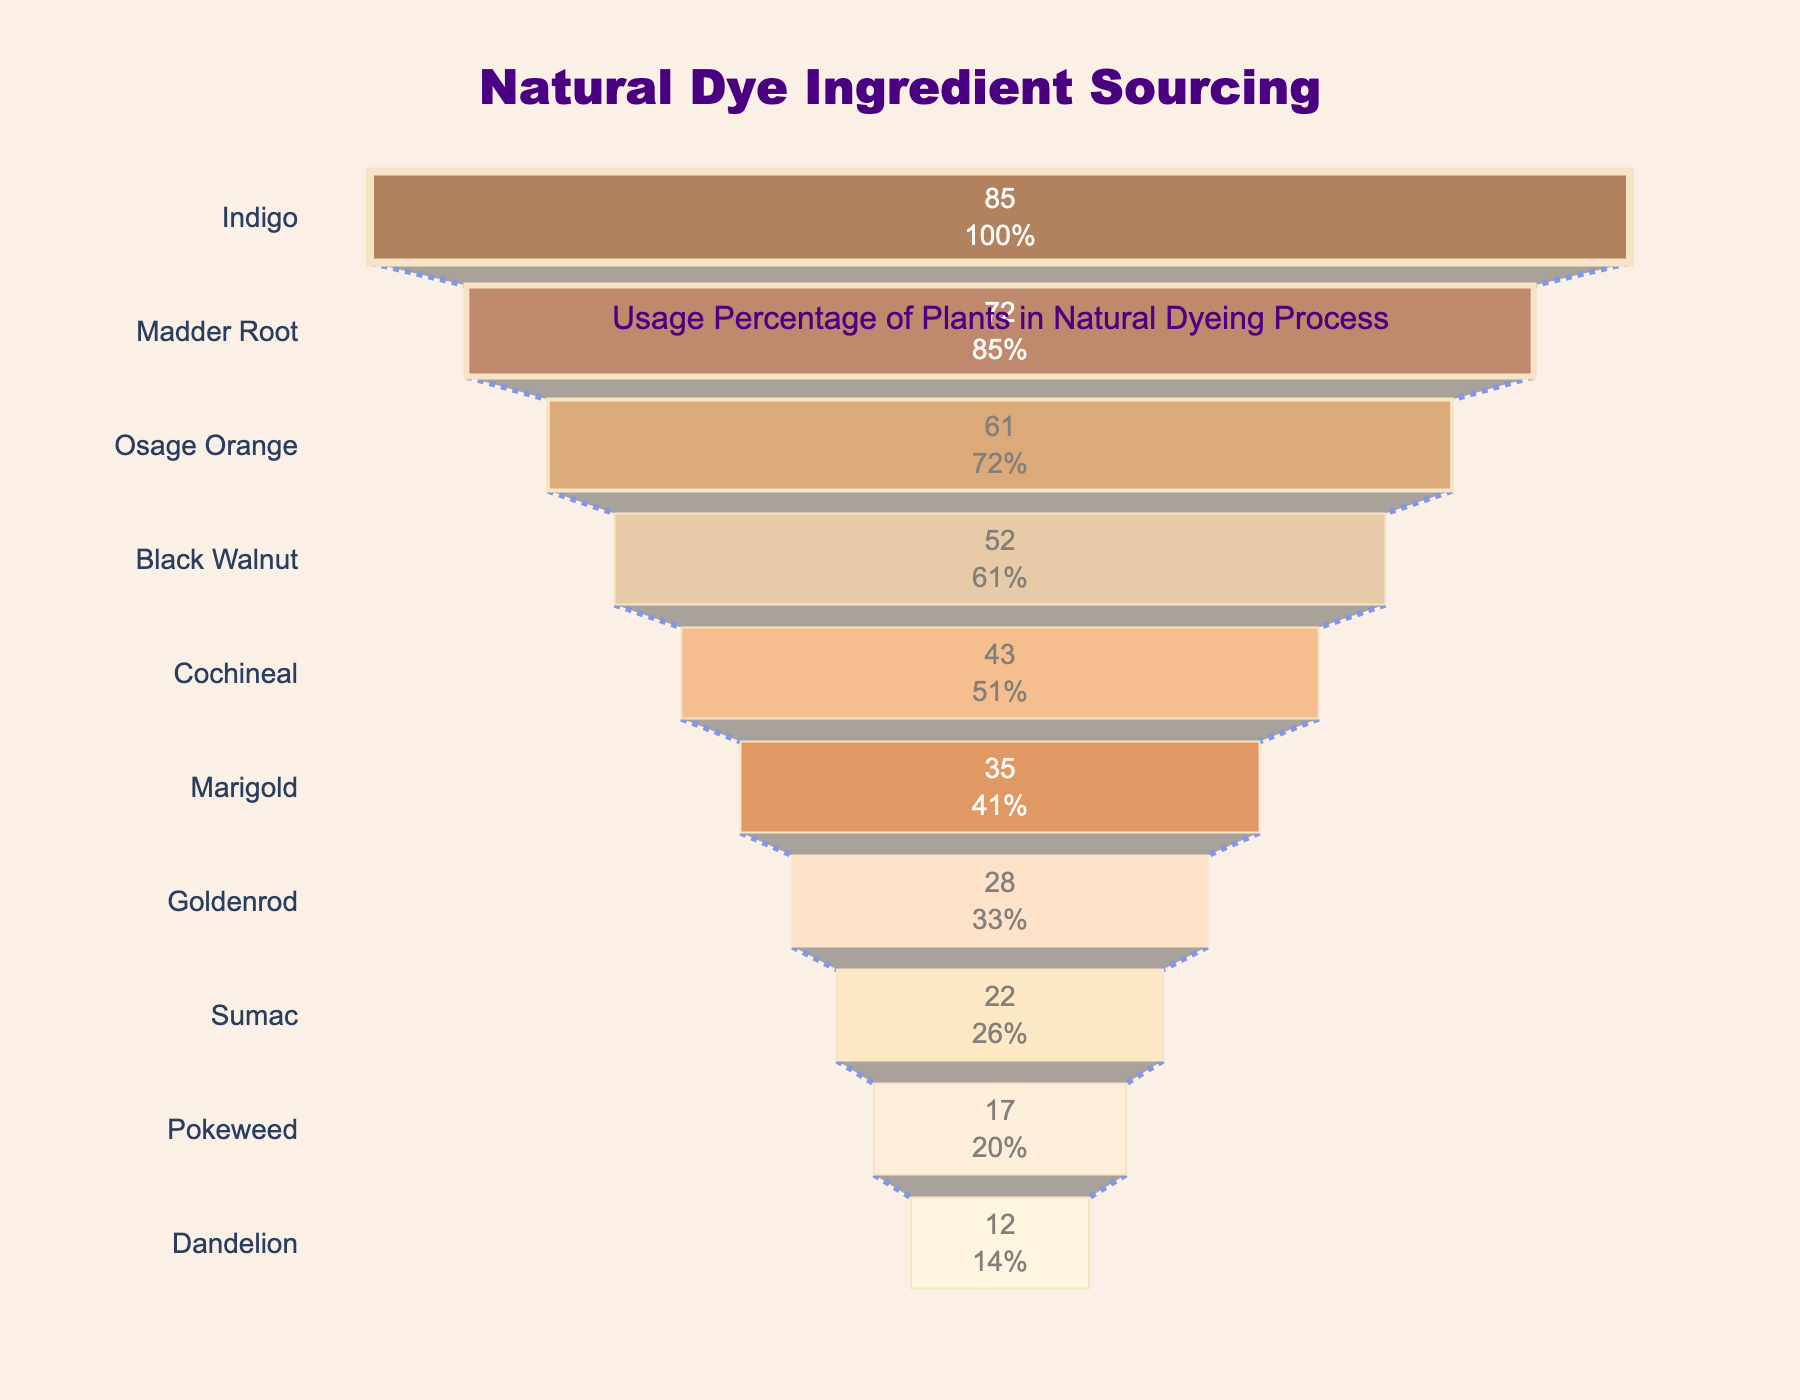What is the title of the funnel chart? The title is written at the top center of the funnel chart in large font. We can read it directly from the chart.
Answer: Natural Dye Ingredient Sourcing Which plant has the highest usage percentage? The plant with the highest usage percentage is at the top of the funnel chart. In this case, it is "Indigo" with a usage percentage of 85%.
Answer: Indigo How many plants have a usage percentage greater than 50%? We look down the funnel chart and count the plants until the percentages drop below 50%. The plants are Indigo, Madder Root, Osage Orange, and Black Walnut.
Answer: 4 What is the usage percentage of Cochineal? The usage percentage of Cochineal can be read directly from its position in the funnel chart.
Answer: 43% Among Marigold and Goldenrod, which plant is used more commonly and by how much percentage? We compare the usage percentages of Marigold and Goldenrod. Marigold is at 35% and Goldenrod at 28%. The difference in percentage is 35% - 28% = 7%.
Answer: Marigold by 7% What is the difference in usage percentage between the plant with the highest and the lowest usage? The highest usage percentage is for Indigo (85%) and the lowest for Dandelion (12%). The difference is calculated as 85% - 12% = 73%.
Answer: 73% How many plants are listed in the funnel chart? We count all the plants listed in the funnel chart from top to bottom. There are 10 plants.
Answer: 10 What is the combined usage percentage of the top three most commonly used plants? We sum the usage percentages of the top three plants: Indigo (85%), Madder Root (72%), and Osage Orange (61%). The combined usage percentage is 85% + 72% + 61% = 218%.
Answer: 218% Which plant is placed directly below Sumac in terms of usage percentage? Sumac is listed above Pokeweed in the funnel chart. Therefore, Pokeweed is directly below Sumac.
Answer: Pokeweed What percentage of users use both Madder Root and Osage Orange, assuming the chart shows unique users for each plant? Since the chart does not provide overlap information and each plant's usage is considered unique, we cannot determine the exact percentage of users using both plants just from the chart.
Answer: Not determinable 